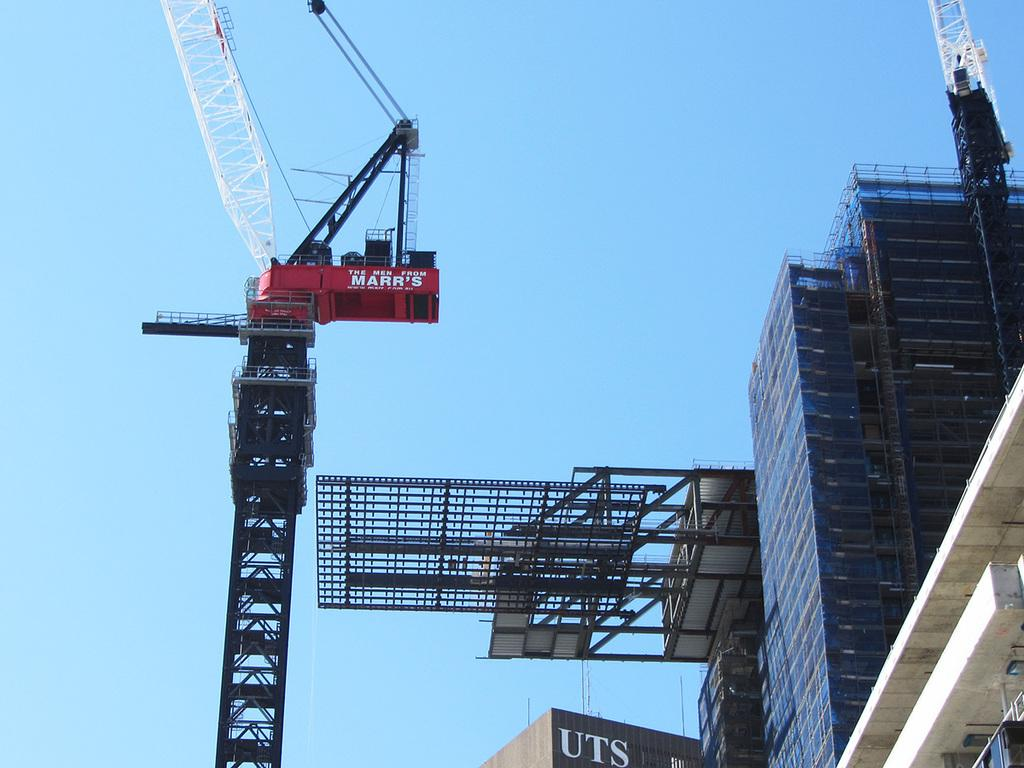What type of machinery is present in the image? There is a crane in the image. What type of structures are visible in the image? There are buildings in the image. What else can be seen in the image besides the crane and buildings? There is text visible in the image. What is the color of the sky in the image? The sky is pale blue in the image. Where is the oven located in the image? There is no oven present in the image. What type of tramp can be seen in the image? There is no tramp present in the image. What emotion is the crane feeling in the image? The crane is an inanimate object and does not have emotions, so it cannot feel regret or any other emotion. 